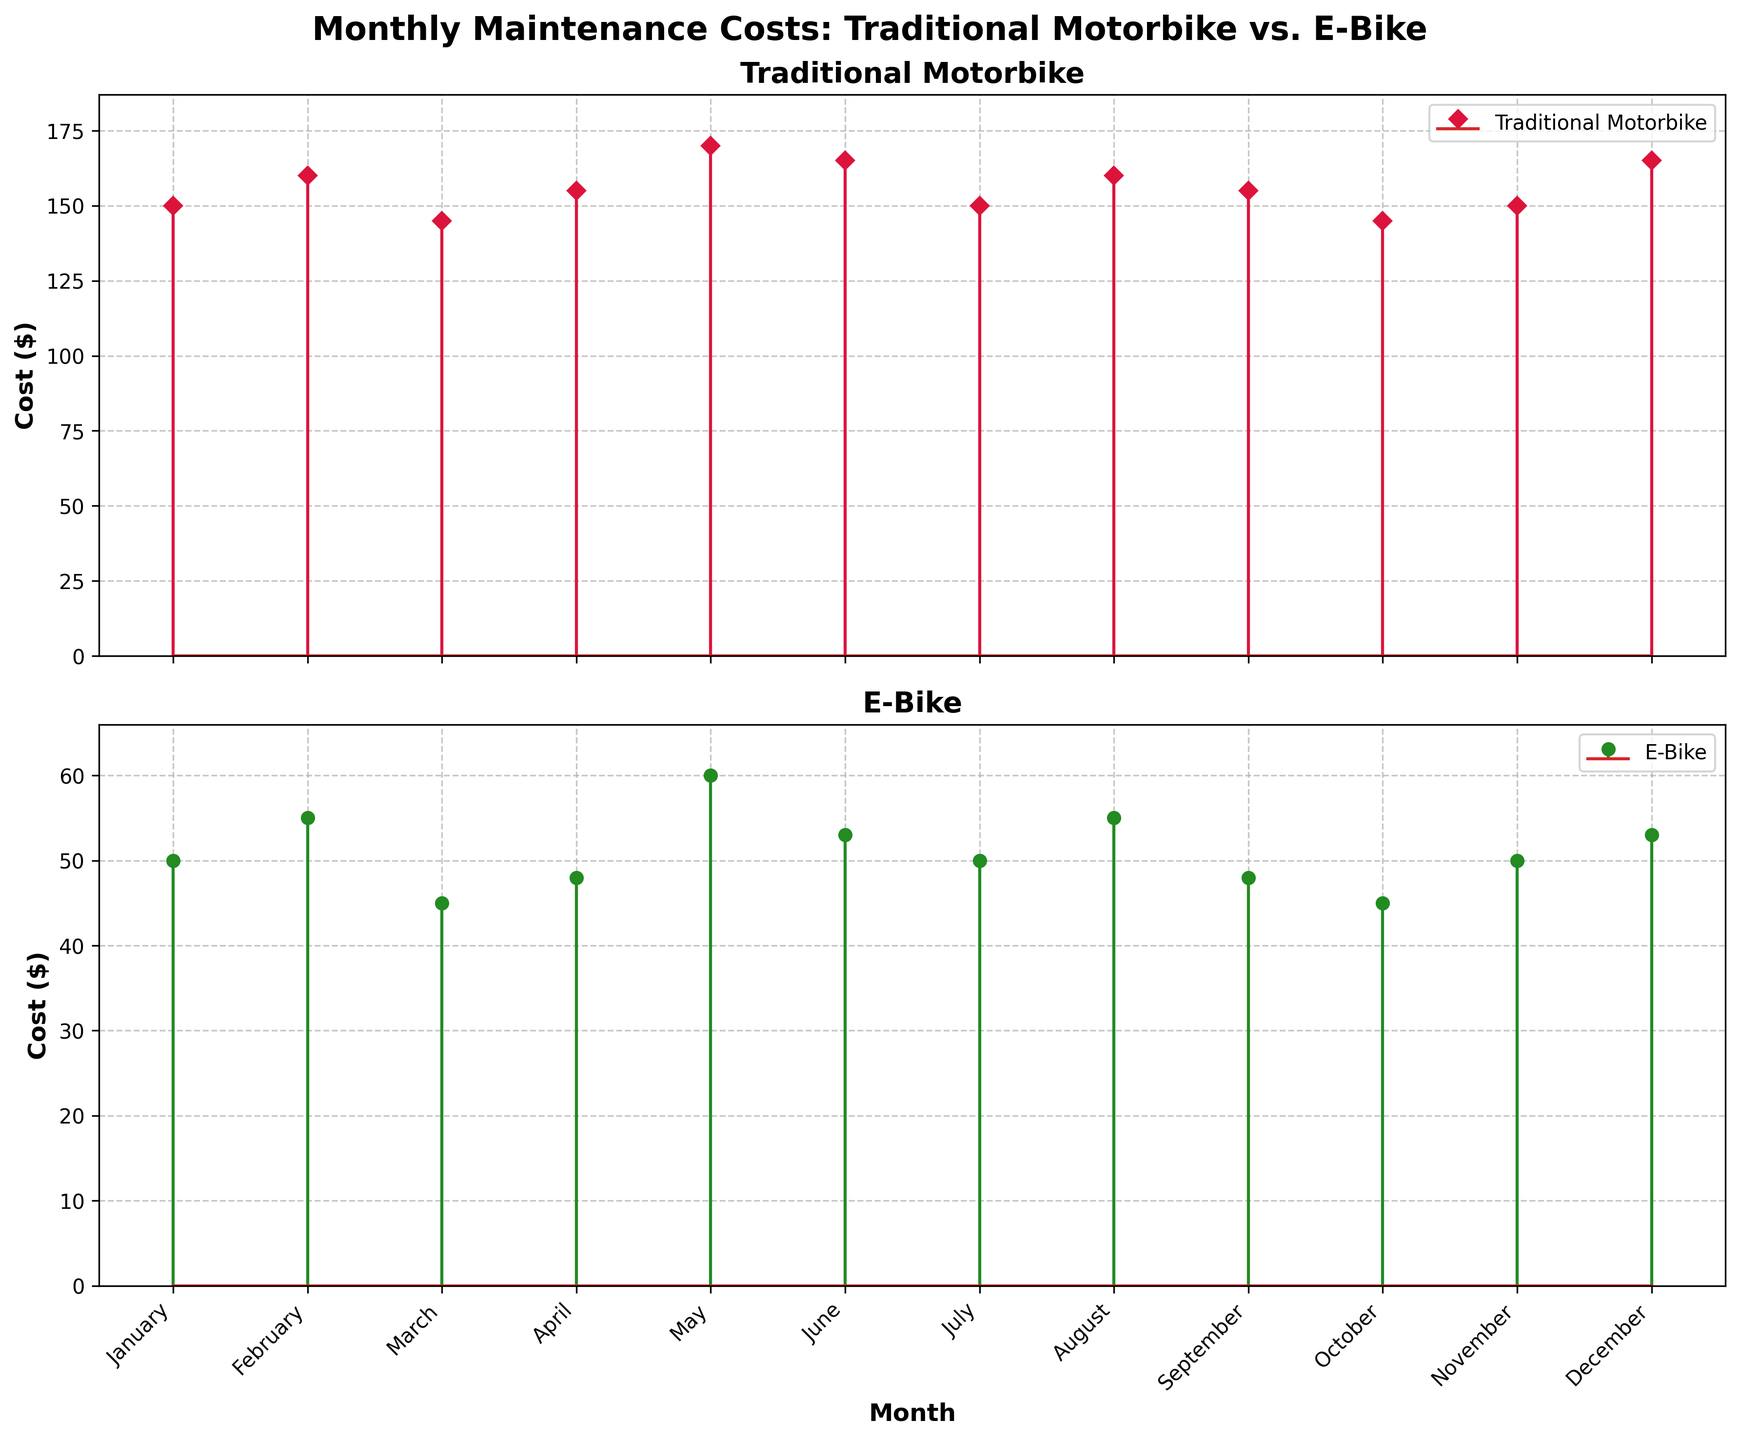What are the titles of the subplots? The titles of the subplots can be found at the top of each subplot. They are usually short descriptions summarizing the data shown. For the Traditional Motorbike subplot, the title is "Traditional Motorbike," and for the E-Bike subplot, the title is "E-Bike."
Answer: Traditional Motorbike, E-Bike Which month has the highest maintenance cost for traditional motorbikes? To find the month with the highest maintenance cost, look at the peaks of the stems in the Traditional Motorbike subplot. The highest value is $170, which occurs in May.
Answer: May How do the maintenance costs compare between traditional motorbikes and e-bikes in May? To compare the maintenance costs, find the costs for both traditional motorbikes and e-bikes in May. For traditional motorbikes, the cost is $170, and for e-bikes, it is $60. This means traditional motorbikes have higher maintenance costs in May.
Answer: Traditional motorbikes are higher What is the average maintenance cost for e-bikes over the entire year? To calculate the average, add up all monthly costs for e-bikes and then divide by the number of months. The total is $50 + $55 + $45 + $48 + $60 + $53 + $50 + $55 + $48 + $45 + $50 + $53 = $612. There are 12 months, so $612 / 12 = $51.
Answer: $51 Which month has the lowest maintenance cost for e-bikes? To determine the month with the lowest cost, look at the shortest stem in the E-Bike subplot. The lowest value is $45, which occurs in March and October.
Answer: March and October Do the traditional motorbike maintenance costs show any seasonal trends? By examining the stem plot for traditional motorbikes, look for patterns over the months. The costs are relatively high in May and June, drop slightly in the following months, and increase again in December, suggesting some fluctuation without a clear seasonal trend.
Answer: No clear seasonal trend What is the difference in maintenance costs between traditional motorbikes and e-bikes in June? Subtract the e-bike cost from the traditional motorbike cost for June. The traditional motorbike cost is $165, and the e-bike cost is $53. So, $165 - $53 = $112.
Answer: $112 How steady are the maintenance costs for e-bikes compared to traditional motorbikes throughout the year? By visually comparing the consistency of the stems' heights in both subplots, you can notice that e-bike maintenance costs range from $45 to $60, showing less variation compared to the traditional motorbike, which ranges from $145 to $170. This indicates more stability in e-bike costs.
Answer: E-bike costs are steadier How many months have exact maintenance costs of $150 for traditional motorbikes? Look for the months where the stem in the Traditional Motorbike subplot reaches the $150 line. These months are January, July, and November. There are three such months.
Answer: 3 